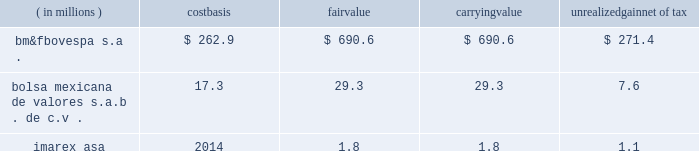Subject to fluctuation and , consequently , the amount realized in the subsequent sale of an investment may differ significantly from its current reported value .
Fluctuations in the market price of a security may result from perceived changes in the underlying economic characteristics of the issuer , the relative price of alternative investments and general market conditions .
The table below summarizes equity investments that are subject to equity price fluctuations at december 31 , 2012 .
Equity investments are included in other assets in our consolidated balance sheets .
( in millions ) carrying unrealized net of tax .
We do not currently hedge against equity price risk .
Equity investments are assessed for other-than- temporary impairment on a quarterly basis. .
What is the unrealized gain pre-tex for bm&fbovespa? 
Computations: (690.6 - 262.9)
Answer: 427.7. 